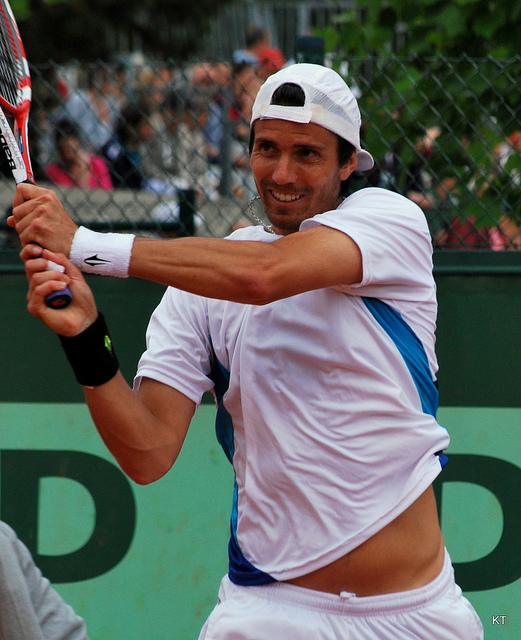What game is this?
Keep it brief. Tennis. What sport is this individual playing?
Write a very short answer. Tennis. Is this a a famous tennis player?
Keep it brief. Yes. Is the man's navel showing?
Keep it brief. No. Does he look happy?
Concise answer only. Yes. What position is he playing?
Keep it brief. Tennis. What sport is this?
Write a very short answer. Tennis. What is the man holding?
Short answer required. Tennis racket. Does the player have a belt?
Give a very brief answer. No. How many gloves is the player wearing?
Write a very short answer. 0. Is the player making an odd face?
Give a very brief answer. No. Is this tee-ball?
Give a very brief answer. No. Is the man holding a bat?
Concise answer only. No. What is he holding?
Answer briefly. Tennis racket. How many fingers is the man holding up?
Quick response, please. 0. What is on the man's wrist?
Write a very short answer. Wristband. What is on the mans right hand?
Short answer required. Wristband. Can you see someone wearing green?
Quick response, please. No. Is the person wearing protective gear?
Be succinct. No. Who is standing in the background?
Concise answer only. Audience. Who is the man looking at?
Answer briefly. Opponent. Is the man's shirt too small?
Short answer required. No. What is this person wearing on their head?
Concise answer only. Hat. 